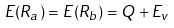<formula> <loc_0><loc_0><loc_500><loc_500>E ( R _ { a } ) = E ( R _ { b } ) = Q + E _ { v }</formula> 